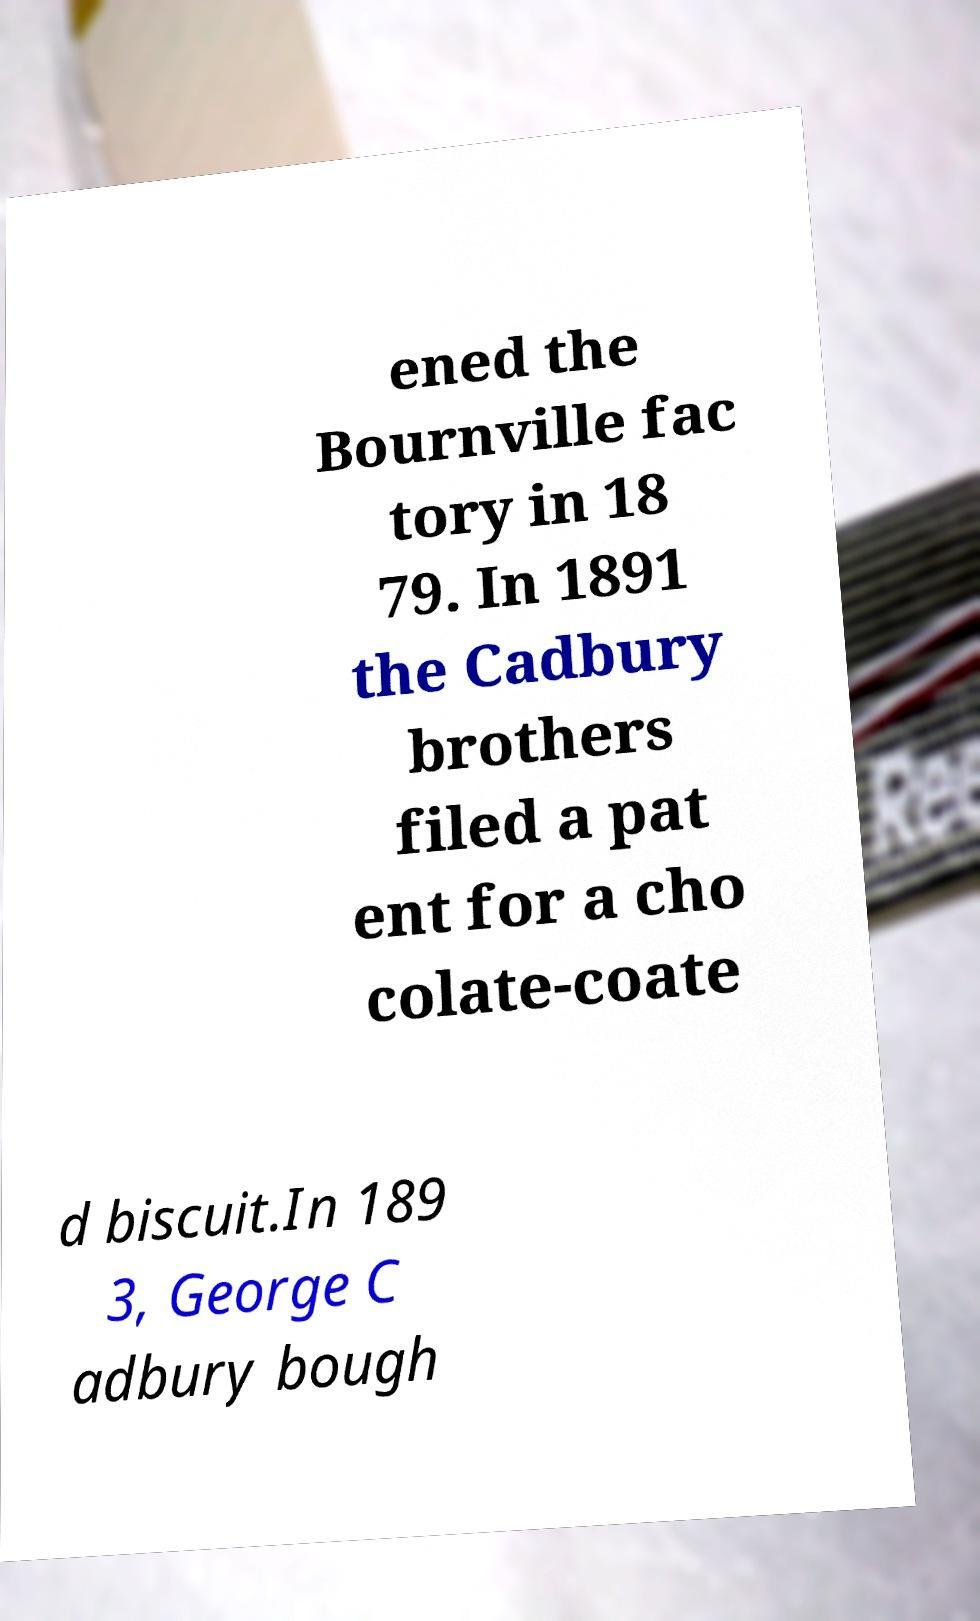Please read and relay the text visible in this image. What does it say? ened the Bournville fac tory in 18 79. In 1891 the Cadbury brothers filed a pat ent for a cho colate-coate d biscuit.In 189 3, George C adbury bough 